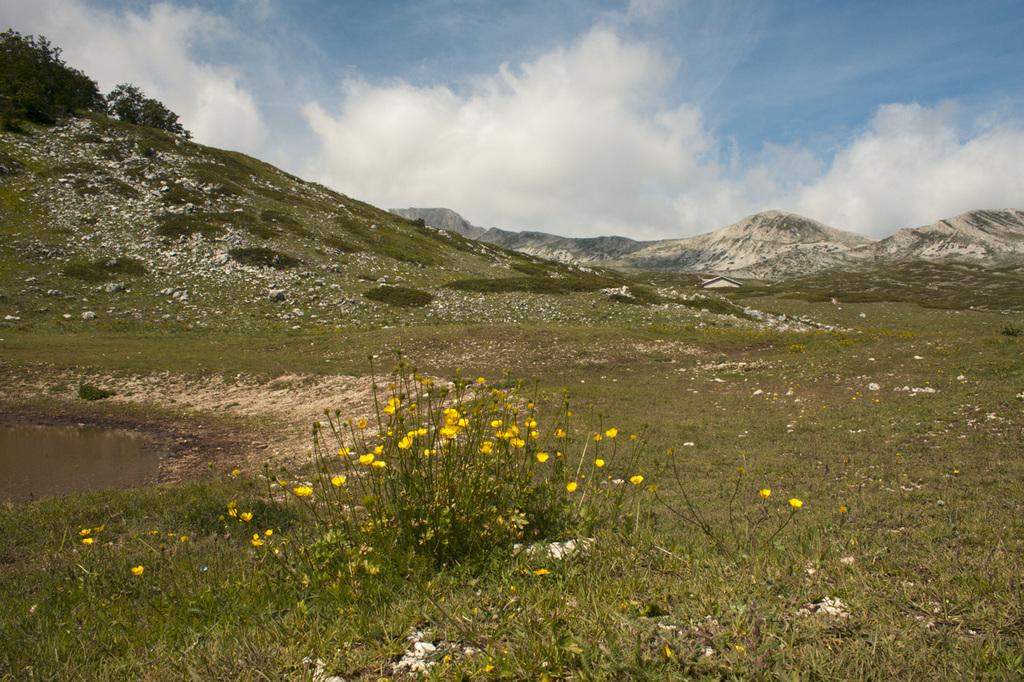What type of plants can be seen in the image? There are flower plants in the image. What color are the flowers? The flowers are yellow in color. What else can be seen in the image besides the flowers? There is water, grass, trees, and mountains visible in the image. What is visible in the background of the image? The sky is visible in the background of the image. How many firemen are present in the image? There are no firemen present in the image. What type of ducks can be seen swimming in the water in the image? There are no ducks present in the image; it only features flower plants, water, grass, trees, mountains, and the sky. 